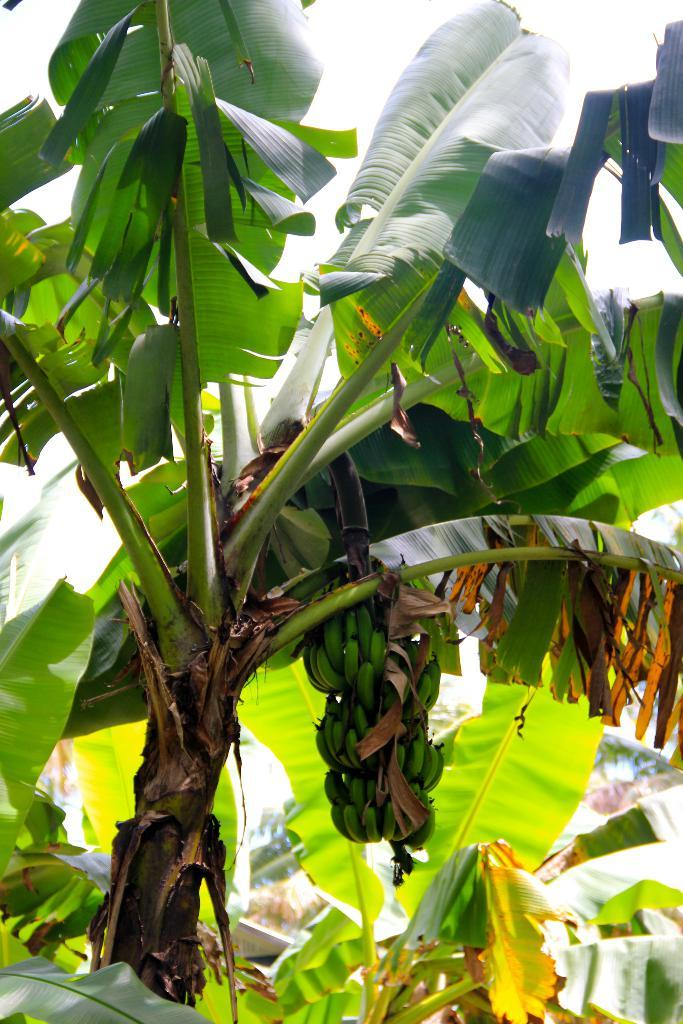What type of tree is present in the image? There is a banana tree in the image. What is the banana tree producing? The banana tree has bananas. How many monkeys are sitting on the banana tree in the image? There are no monkeys present in the image; it only features a banana tree with bananas. What part of the human body is visible in the image? There are no human body parts visible in the image; it only features a banana tree with bananas. 